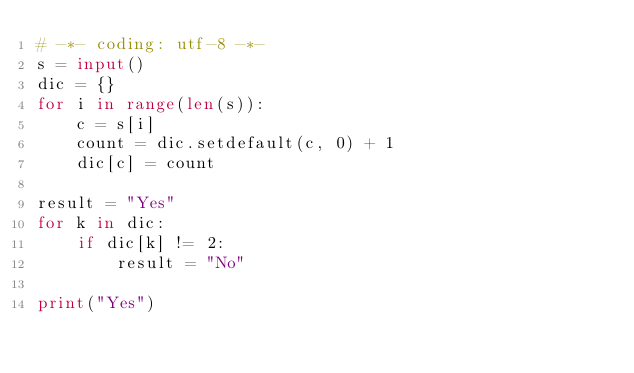<code> <loc_0><loc_0><loc_500><loc_500><_Python_># -*- coding: utf-8 -*-
s = input()
dic = {}
for i in range(len(s)):
    c = s[i]
    count = dic.setdefault(c, 0) + 1
    dic[c] = count

result = "Yes"
for k in dic:
    if dic[k] != 2:
        result = "No"

print("Yes")
</code> 